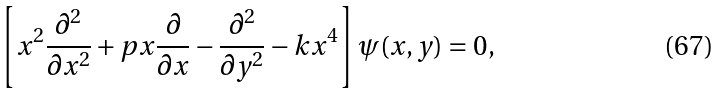<formula> <loc_0><loc_0><loc_500><loc_500>\left [ x ^ { 2 } \frac { \partial ^ { 2 } } { \partial x ^ { 2 } } + p x \frac { \partial } { \partial x } - \frac { \partial ^ { 2 } } { \partial y ^ { 2 } } - k x ^ { 4 } \right ] \psi ( x , y ) = 0 ,</formula> 